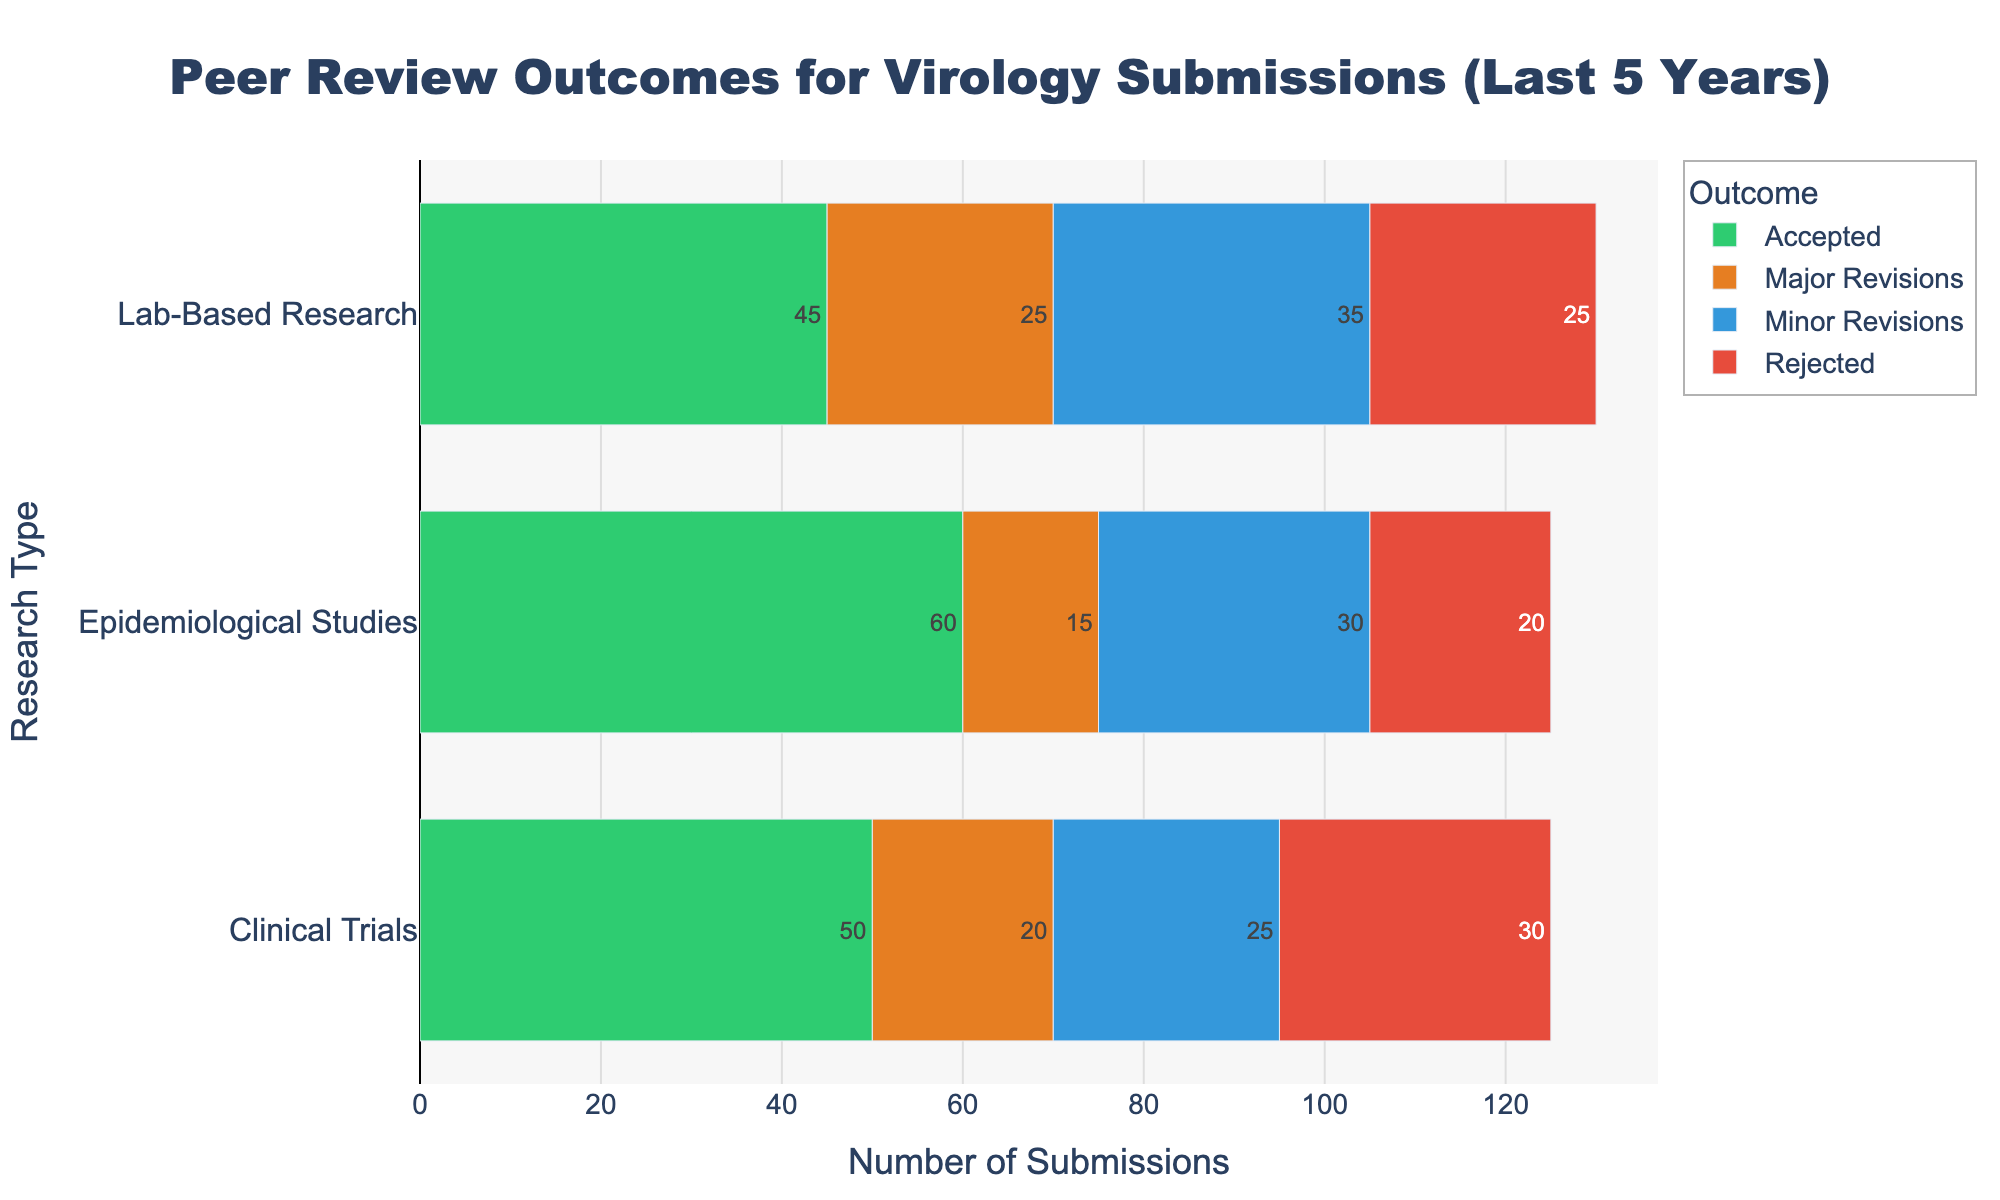What is the total number of submissions for Clinical Trials? Add the counts for all outcomes in Clinical Trials: 50 (Accepted) + 20 (Major Revisions) + 25 (Minor Revisions) + 30 (Rejected) = 125
Answer: 125 Which research type has the highest number of Major Revisions? Compare the counts for Major Revisions across all research types. Clinical Trials have 20, Epidemiological Studies have 15, and Lab-Based Research has 25. Therefore, Lab-Based Research has the highest number of Major Revisions
Answer: Lab-Based Research How many more submissions were accepted than rejected in Epidemiological Studies? Subtract the number of rejected submissions from the accepted submissions in Epidemiological Studies: 60 (Accepted) - 20 (Rejected) = 40
Answer: 40 What is the total number of submissions with Minor Revisions for all research types? Add the counts for Minor Revisions across all research types: 25 (Clinical Trials) + 30 (Epidemiological Studies) + 35 (Lab-Based Research) = 90
Answer: 90 Which outcome has the smallest number of submissions in Clinical Trials? Compare the counts for all outcomes in Clinical Trials: Accepted - 50, Major Revisions - 20, Minor Revisions - 25, Rejected - 30. The smallest count is for Major Revisions, which is 20
Answer: Major Revisions What is the combined count of accepted submissions for Clinical Trials and Lab-Based Research? Add the number of accepted submissions in Clinical Trials and Lab-Based Research: 50 (Clinical Trials) + 45 (Lab-Based Research) = 95
Answer: 95 Which research type has the most balanced distribution of outcomes? Check the distribution of submission counts for each research type across different outcomes. Lab-Based Research has counts of 45 (Accepted), 25 (Major Revisions), 35 (Minor Revisions), 25 (Rejected), with numbers relatively close to each other compared to Clinical Trials and Epidemiological Studies
Answer: Lab-Based Research Is the number of rejected submissions for Lab-Based Research greater than that for Epidemiological Studies? Compare the number of rejected submissions: Lab-Based Research has 25, while Epidemiological Studies have 20. Since 25 > 20, Lab-Based Research has more rejected submissions
Answer: Yes What percentage of submissions for Epidemiological Studies were accepted? Calculate the percentage using the formula (Accepted / Total) * 100. For Epidemiological Studies, it's (60 / (60 + 15 + 30 + 20)) * 100 = (60 / 125) * 100 ≈ 48%
Answer: 48% Which outcome in Lab-Based Research has the highest submission count? Compare the submission counts for all outcomes in Lab-Based Research: Accepted - 45, Major Revisions - 25, Minor Revisions - 35, Rejected - 25. The highest count is for Accepted, with 45 submissions
Answer: Accepted 